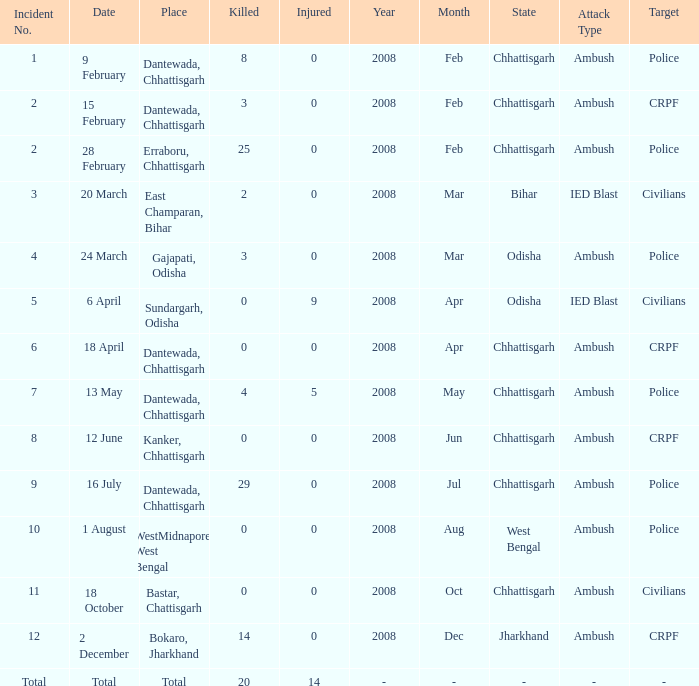How many people were injured in total in East Champaran, Bihar with more than 2 people killed? 0.0. 